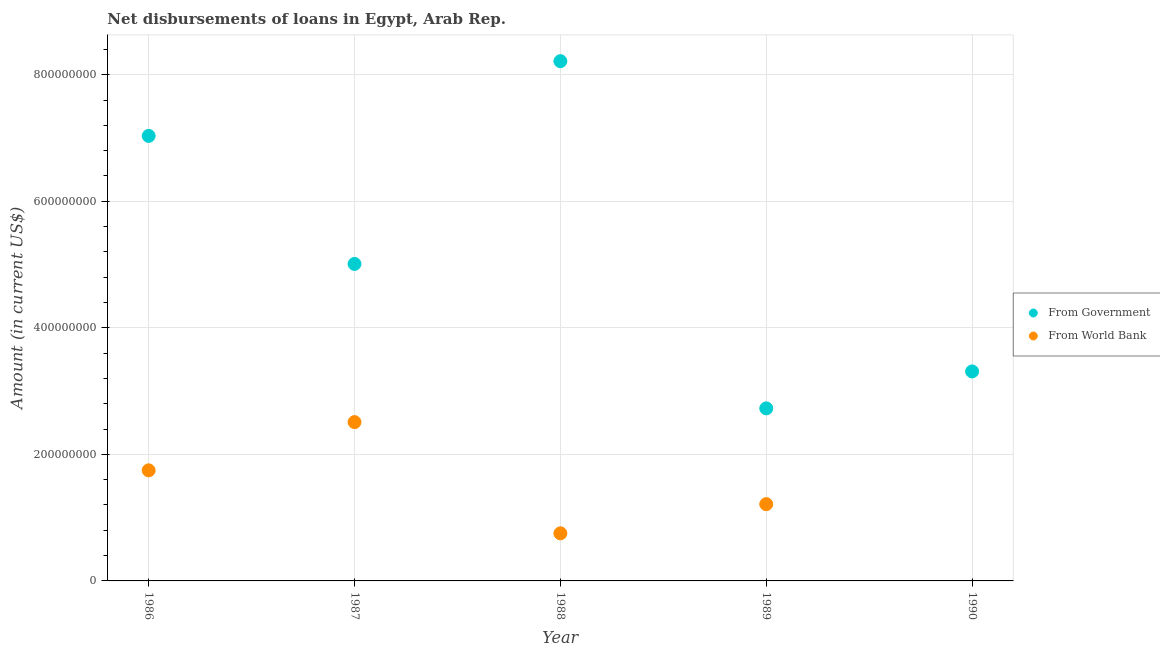Is the number of dotlines equal to the number of legend labels?
Offer a terse response. No. What is the net disbursements of loan from government in 1988?
Make the answer very short. 8.21e+08. Across all years, what is the maximum net disbursements of loan from world bank?
Your response must be concise. 2.51e+08. Across all years, what is the minimum net disbursements of loan from world bank?
Offer a terse response. 0. In which year was the net disbursements of loan from government maximum?
Offer a very short reply. 1988. What is the total net disbursements of loan from government in the graph?
Give a very brief answer. 2.63e+09. What is the difference between the net disbursements of loan from world bank in 1986 and that in 1987?
Ensure brevity in your answer.  -7.62e+07. What is the difference between the net disbursements of loan from government in 1989 and the net disbursements of loan from world bank in 1990?
Your answer should be very brief. 2.73e+08. What is the average net disbursements of loan from government per year?
Provide a short and direct response. 5.26e+08. In the year 1986, what is the difference between the net disbursements of loan from government and net disbursements of loan from world bank?
Offer a very short reply. 5.29e+08. In how many years, is the net disbursements of loan from world bank greater than 520000000 US$?
Offer a very short reply. 0. What is the ratio of the net disbursements of loan from government in 1987 to that in 1988?
Your answer should be compact. 0.61. What is the difference between the highest and the second highest net disbursements of loan from government?
Make the answer very short. 1.18e+08. What is the difference between the highest and the lowest net disbursements of loan from government?
Ensure brevity in your answer.  5.49e+08. Is the sum of the net disbursements of loan from world bank in 1986 and 1988 greater than the maximum net disbursements of loan from government across all years?
Your answer should be very brief. No. Does the net disbursements of loan from world bank monotonically increase over the years?
Your response must be concise. No. Is the net disbursements of loan from government strictly greater than the net disbursements of loan from world bank over the years?
Give a very brief answer. Yes. How many years are there in the graph?
Offer a very short reply. 5. Does the graph contain grids?
Provide a succinct answer. Yes. How many legend labels are there?
Offer a very short reply. 2. How are the legend labels stacked?
Offer a terse response. Vertical. What is the title of the graph?
Your answer should be compact. Net disbursements of loans in Egypt, Arab Rep. What is the label or title of the Y-axis?
Offer a very short reply. Amount (in current US$). What is the Amount (in current US$) of From Government in 1986?
Give a very brief answer. 7.03e+08. What is the Amount (in current US$) in From World Bank in 1986?
Keep it short and to the point. 1.75e+08. What is the Amount (in current US$) in From Government in 1987?
Your answer should be compact. 5.01e+08. What is the Amount (in current US$) of From World Bank in 1987?
Offer a terse response. 2.51e+08. What is the Amount (in current US$) in From Government in 1988?
Your answer should be very brief. 8.21e+08. What is the Amount (in current US$) in From World Bank in 1988?
Provide a short and direct response. 7.52e+07. What is the Amount (in current US$) in From Government in 1989?
Make the answer very short. 2.73e+08. What is the Amount (in current US$) of From World Bank in 1989?
Your answer should be very brief. 1.21e+08. What is the Amount (in current US$) of From Government in 1990?
Offer a very short reply. 3.31e+08. What is the Amount (in current US$) in From World Bank in 1990?
Make the answer very short. 0. Across all years, what is the maximum Amount (in current US$) in From Government?
Your answer should be compact. 8.21e+08. Across all years, what is the maximum Amount (in current US$) in From World Bank?
Provide a short and direct response. 2.51e+08. Across all years, what is the minimum Amount (in current US$) in From Government?
Keep it short and to the point. 2.73e+08. Across all years, what is the minimum Amount (in current US$) of From World Bank?
Your answer should be very brief. 0. What is the total Amount (in current US$) in From Government in the graph?
Ensure brevity in your answer.  2.63e+09. What is the total Amount (in current US$) of From World Bank in the graph?
Your response must be concise. 6.22e+08. What is the difference between the Amount (in current US$) in From Government in 1986 and that in 1987?
Your response must be concise. 2.02e+08. What is the difference between the Amount (in current US$) in From World Bank in 1986 and that in 1987?
Ensure brevity in your answer.  -7.62e+07. What is the difference between the Amount (in current US$) in From Government in 1986 and that in 1988?
Provide a short and direct response. -1.18e+08. What is the difference between the Amount (in current US$) in From World Bank in 1986 and that in 1988?
Offer a terse response. 9.96e+07. What is the difference between the Amount (in current US$) in From Government in 1986 and that in 1989?
Your response must be concise. 4.31e+08. What is the difference between the Amount (in current US$) of From World Bank in 1986 and that in 1989?
Offer a terse response. 5.34e+07. What is the difference between the Amount (in current US$) of From Government in 1986 and that in 1990?
Ensure brevity in your answer.  3.72e+08. What is the difference between the Amount (in current US$) in From Government in 1987 and that in 1988?
Provide a succinct answer. -3.20e+08. What is the difference between the Amount (in current US$) in From World Bank in 1987 and that in 1988?
Provide a succinct answer. 1.76e+08. What is the difference between the Amount (in current US$) in From Government in 1987 and that in 1989?
Offer a terse response. 2.28e+08. What is the difference between the Amount (in current US$) of From World Bank in 1987 and that in 1989?
Your answer should be compact. 1.30e+08. What is the difference between the Amount (in current US$) in From Government in 1987 and that in 1990?
Make the answer very short. 1.70e+08. What is the difference between the Amount (in current US$) of From Government in 1988 and that in 1989?
Give a very brief answer. 5.49e+08. What is the difference between the Amount (in current US$) in From World Bank in 1988 and that in 1989?
Your response must be concise. -4.61e+07. What is the difference between the Amount (in current US$) of From Government in 1988 and that in 1990?
Make the answer very short. 4.90e+08. What is the difference between the Amount (in current US$) of From Government in 1989 and that in 1990?
Provide a succinct answer. -5.84e+07. What is the difference between the Amount (in current US$) in From Government in 1986 and the Amount (in current US$) in From World Bank in 1987?
Offer a terse response. 4.52e+08. What is the difference between the Amount (in current US$) in From Government in 1986 and the Amount (in current US$) in From World Bank in 1988?
Provide a short and direct response. 6.28e+08. What is the difference between the Amount (in current US$) of From Government in 1986 and the Amount (in current US$) of From World Bank in 1989?
Your answer should be compact. 5.82e+08. What is the difference between the Amount (in current US$) in From Government in 1987 and the Amount (in current US$) in From World Bank in 1988?
Keep it short and to the point. 4.26e+08. What is the difference between the Amount (in current US$) in From Government in 1987 and the Amount (in current US$) in From World Bank in 1989?
Keep it short and to the point. 3.80e+08. What is the difference between the Amount (in current US$) of From Government in 1988 and the Amount (in current US$) of From World Bank in 1989?
Provide a succinct answer. 7.00e+08. What is the average Amount (in current US$) in From Government per year?
Your answer should be very brief. 5.26e+08. What is the average Amount (in current US$) of From World Bank per year?
Provide a succinct answer. 1.24e+08. In the year 1986, what is the difference between the Amount (in current US$) of From Government and Amount (in current US$) of From World Bank?
Your response must be concise. 5.29e+08. In the year 1987, what is the difference between the Amount (in current US$) of From Government and Amount (in current US$) of From World Bank?
Provide a succinct answer. 2.50e+08. In the year 1988, what is the difference between the Amount (in current US$) of From Government and Amount (in current US$) of From World Bank?
Give a very brief answer. 7.46e+08. In the year 1989, what is the difference between the Amount (in current US$) in From Government and Amount (in current US$) in From World Bank?
Give a very brief answer. 1.51e+08. What is the ratio of the Amount (in current US$) of From Government in 1986 to that in 1987?
Your response must be concise. 1.4. What is the ratio of the Amount (in current US$) in From World Bank in 1986 to that in 1987?
Provide a short and direct response. 0.7. What is the ratio of the Amount (in current US$) of From Government in 1986 to that in 1988?
Provide a succinct answer. 0.86. What is the ratio of the Amount (in current US$) in From World Bank in 1986 to that in 1988?
Give a very brief answer. 2.32. What is the ratio of the Amount (in current US$) in From Government in 1986 to that in 1989?
Your answer should be compact. 2.58. What is the ratio of the Amount (in current US$) in From World Bank in 1986 to that in 1989?
Your answer should be compact. 1.44. What is the ratio of the Amount (in current US$) in From Government in 1986 to that in 1990?
Your answer should be very brief. 2.12. What is the ratio of the Amount (in current US$) of From Government in 1987 to that in 1988?
Your response must be concise. 0.61. What is the ratio of the Amount (in current US$) in From World Bank in 1987 to that in 1988?
Provide a succinct answer. 3.34. What is the ratio of the Amount (in current US$) in From Government in 1987 to that in 1989?
Make the answer very short. 1.84. What is the ratio of the Amount (in current US$) of From World Bank in 1987 to that in 1989?
Provide a succinct answer. 2.07. What is the ratio of the Amount (in current US$) of From Government in 1987 to that in 1990?
Give a very brief answer. 1.51. What is the ratio of the Amount (in current US$) of From Government in 1988 to that in 1989?
Offer a terse response. 3.01. What is the ratio of the Amount (in current US$) in From World Bank in 1988 to that in 1989?
Provide a succinct answer. 0.62. What is the ratio of the Amount (in current US$) in From Government in 1988 to that in 1990?
Your answer should be compact. 2.48. What is the ratio of the Amount (in current US$) of From Government in 1989 to that in 1990?
Your answer should be compact. 0.82. What is the difference between the highest and the second highest Amount (in current US$) of From Government?
Ensure brevity in your answer.  1.18e+08. What is the difference between the highest and the second highest Amount (in current US$) of From World Bank?
Your answer should be very brief. 7.62e+07. What is the difference between the highest and the lowest Amount (in current US$) of From Government?
Give a very brief answer. 5.49e+08. What is the difference between the highest and the lowest Amount (in current US$) in From World Bank?
Offer a terse response. 2.51e+08. 